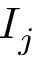<formula> <loc_0><loc_0><loc_500><loc_500>I _ { j }</formula> 